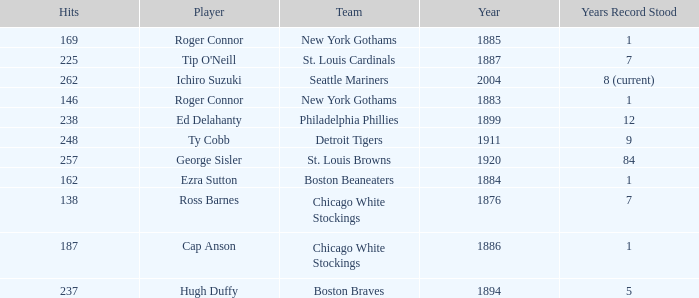Name the least hits for year less than 1920 and player of ed delahanty 238.0. 